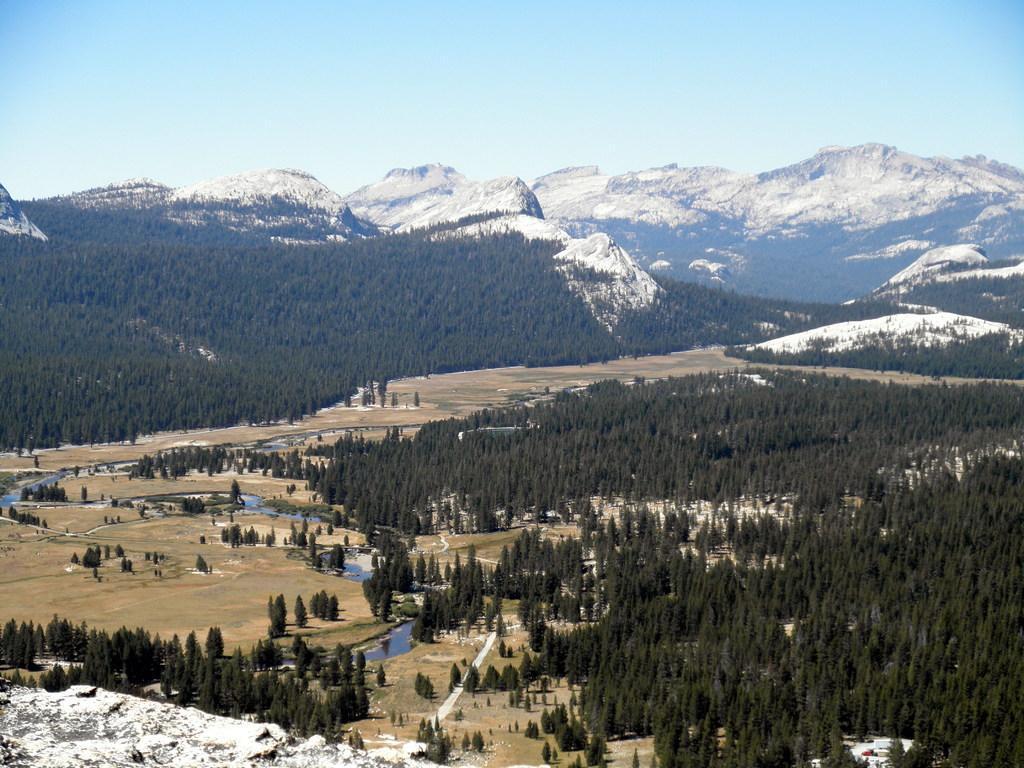Describe this image in one or two sentences. Here we can see a number of trees. Background there are mountains. Sky is in blue color. 